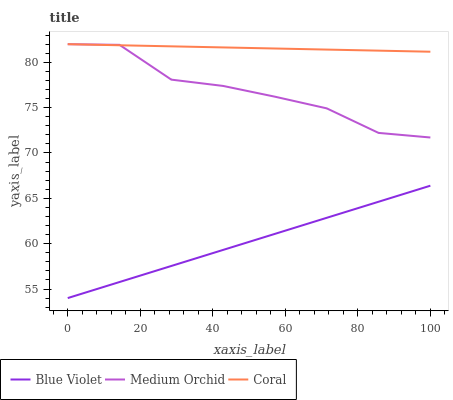Does Blue Violet have the minimum area under the curve?
Answer yes or no. Yes. Does Coral have the maximum area under the curve?
Answer yes or no. Yes. Does Medium Orchid have the minimum area under the curve?
Answer yes or no. No. Does Medium Orchid have the maximum area under the curve?
Answer yes or no. No. Is Blue Violet the smoothest?
Answer yes or no. Yes. Is Medium Orchid the roughest?
Answer yes or no. Yes. Is Medium Orchid the smoothest?
Answer yes or no. No. Is Blue Violet the roughest?
Answer yes or no. No. Does Blue Violet have the lowest value?
Answer yes or no. Yes. Does Medium Orchid have the lowest value?
Answer yes or no. No. Does Medium Orchid have the highest value?
Answer yes or no. Yes. Does Blue Violet have the highest value?
Answer yes or no. No. Is Blue Violet less than Coral?
Answer yes or no. Yes. Is Coral greater than Blue Violet?
Answer yes or no. Yes. Does Medium Orchid intersect Coral?
Answer yes or no. Yes. Is Medium Orchid less than Coral?
Answer yes or no. No. Is Medium Orchid greater than Coral?
Answer yes or no. No. Does Blue Violet intersect Coral?
Answer yes or no. No. 